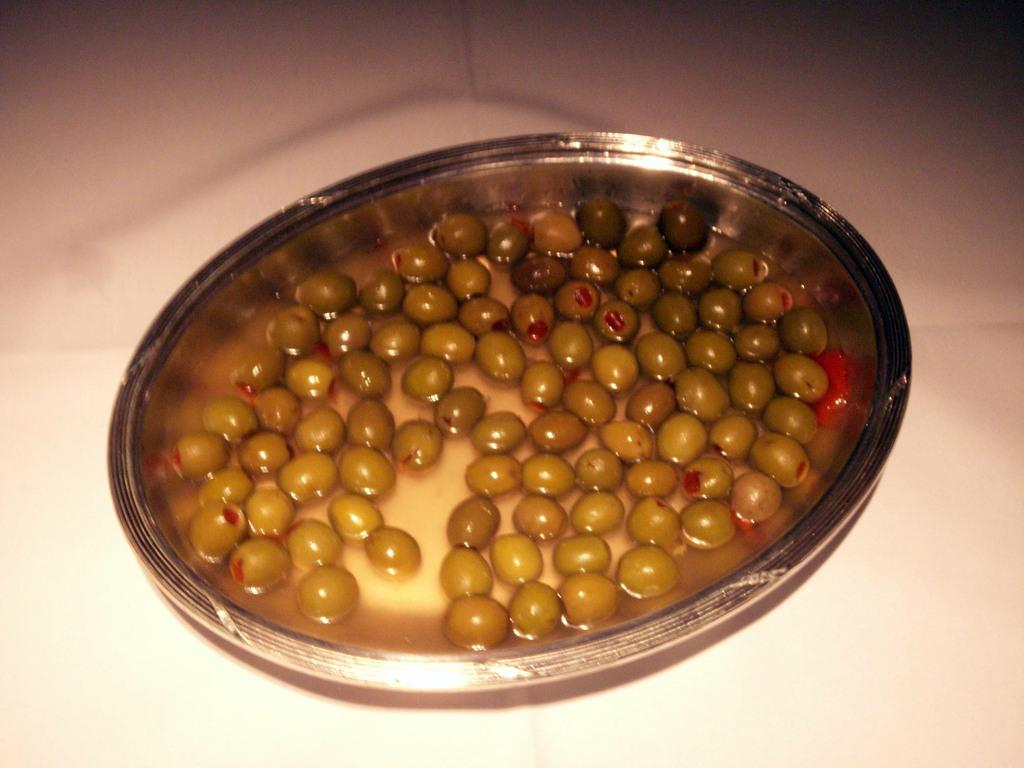What type of food can be seen in the image? There are olives in the image. What else is present in the image besides the olives? There is water in the image. How are the olives and water contained in the image? The olives and water are in a bowl. Where is the bowl placed in the image? The bowl is placed on a surface. What direction is the head facing in the image? There is no head present in the image; it features olives and water in a bowl. What type of cream is visible in the image? There is no cream present in the image; it features olives and water in a bowl. 